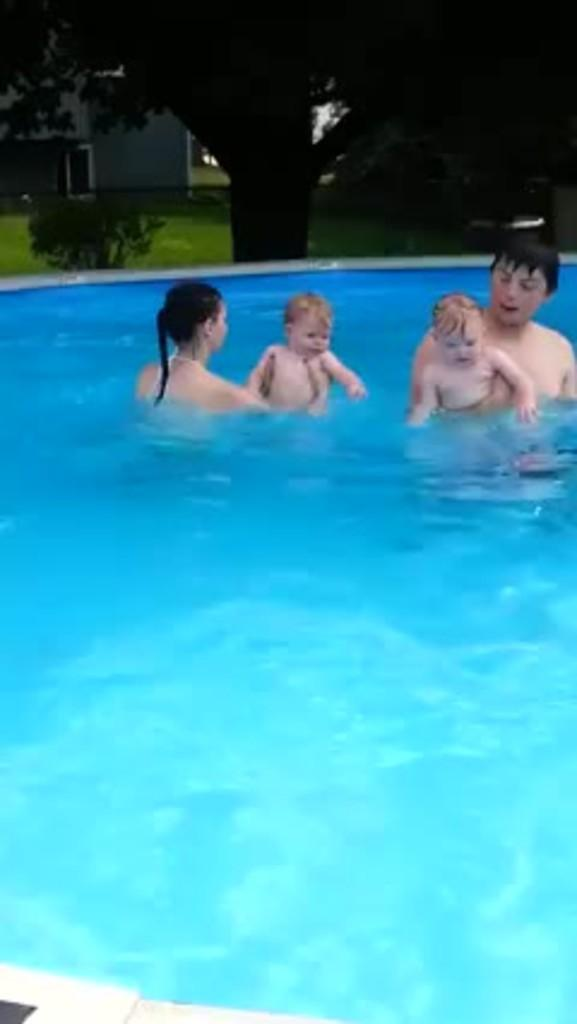Who is present in the image? There is a man and a woman in the image. What are the man and woman doing in the image? They are swimming in the swimming pool and holding two kids. What can be seen in the background of the image? There are trees, plants, and a building in the backdrop of the image. What type of humor is being shared between the man and woman in the image? There is no indication of humor being shared between the man and woman in the image. What month is it in the image? The month cannot be determined from the image. 